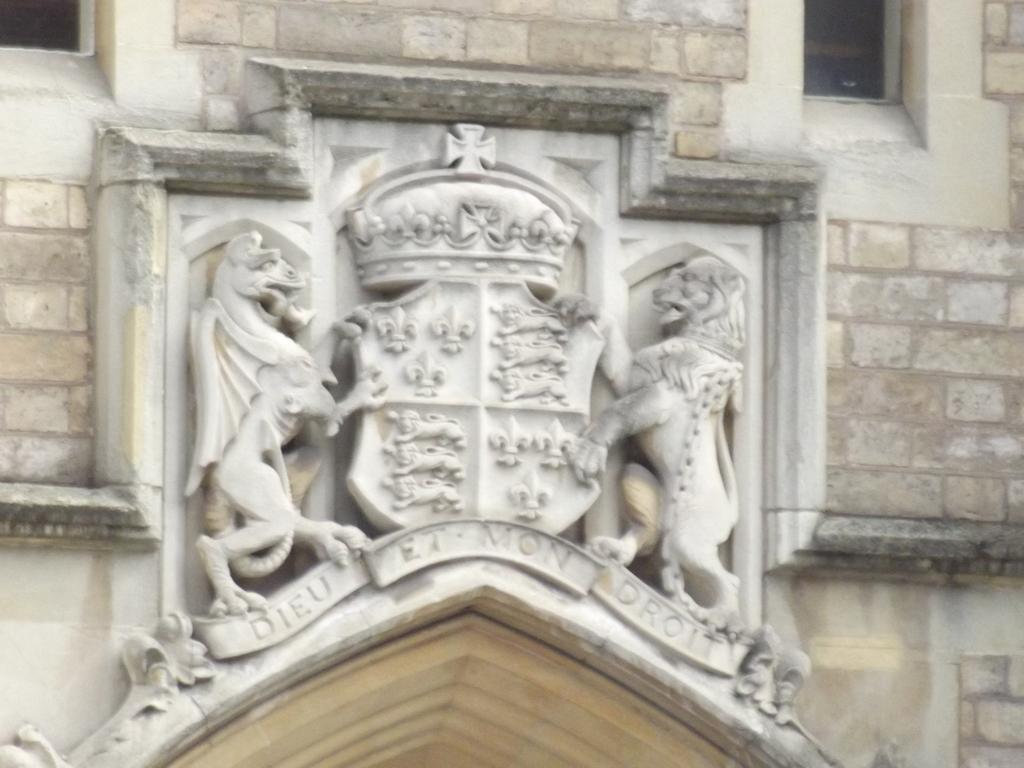What is the main subject of the image? The main subject of the image is a building. Are there any additional features on the building? Yes, there are structures on the building. What type of treatment is being administered to the building in the image? There is no indication in the image that the building is receiving any treatment. 